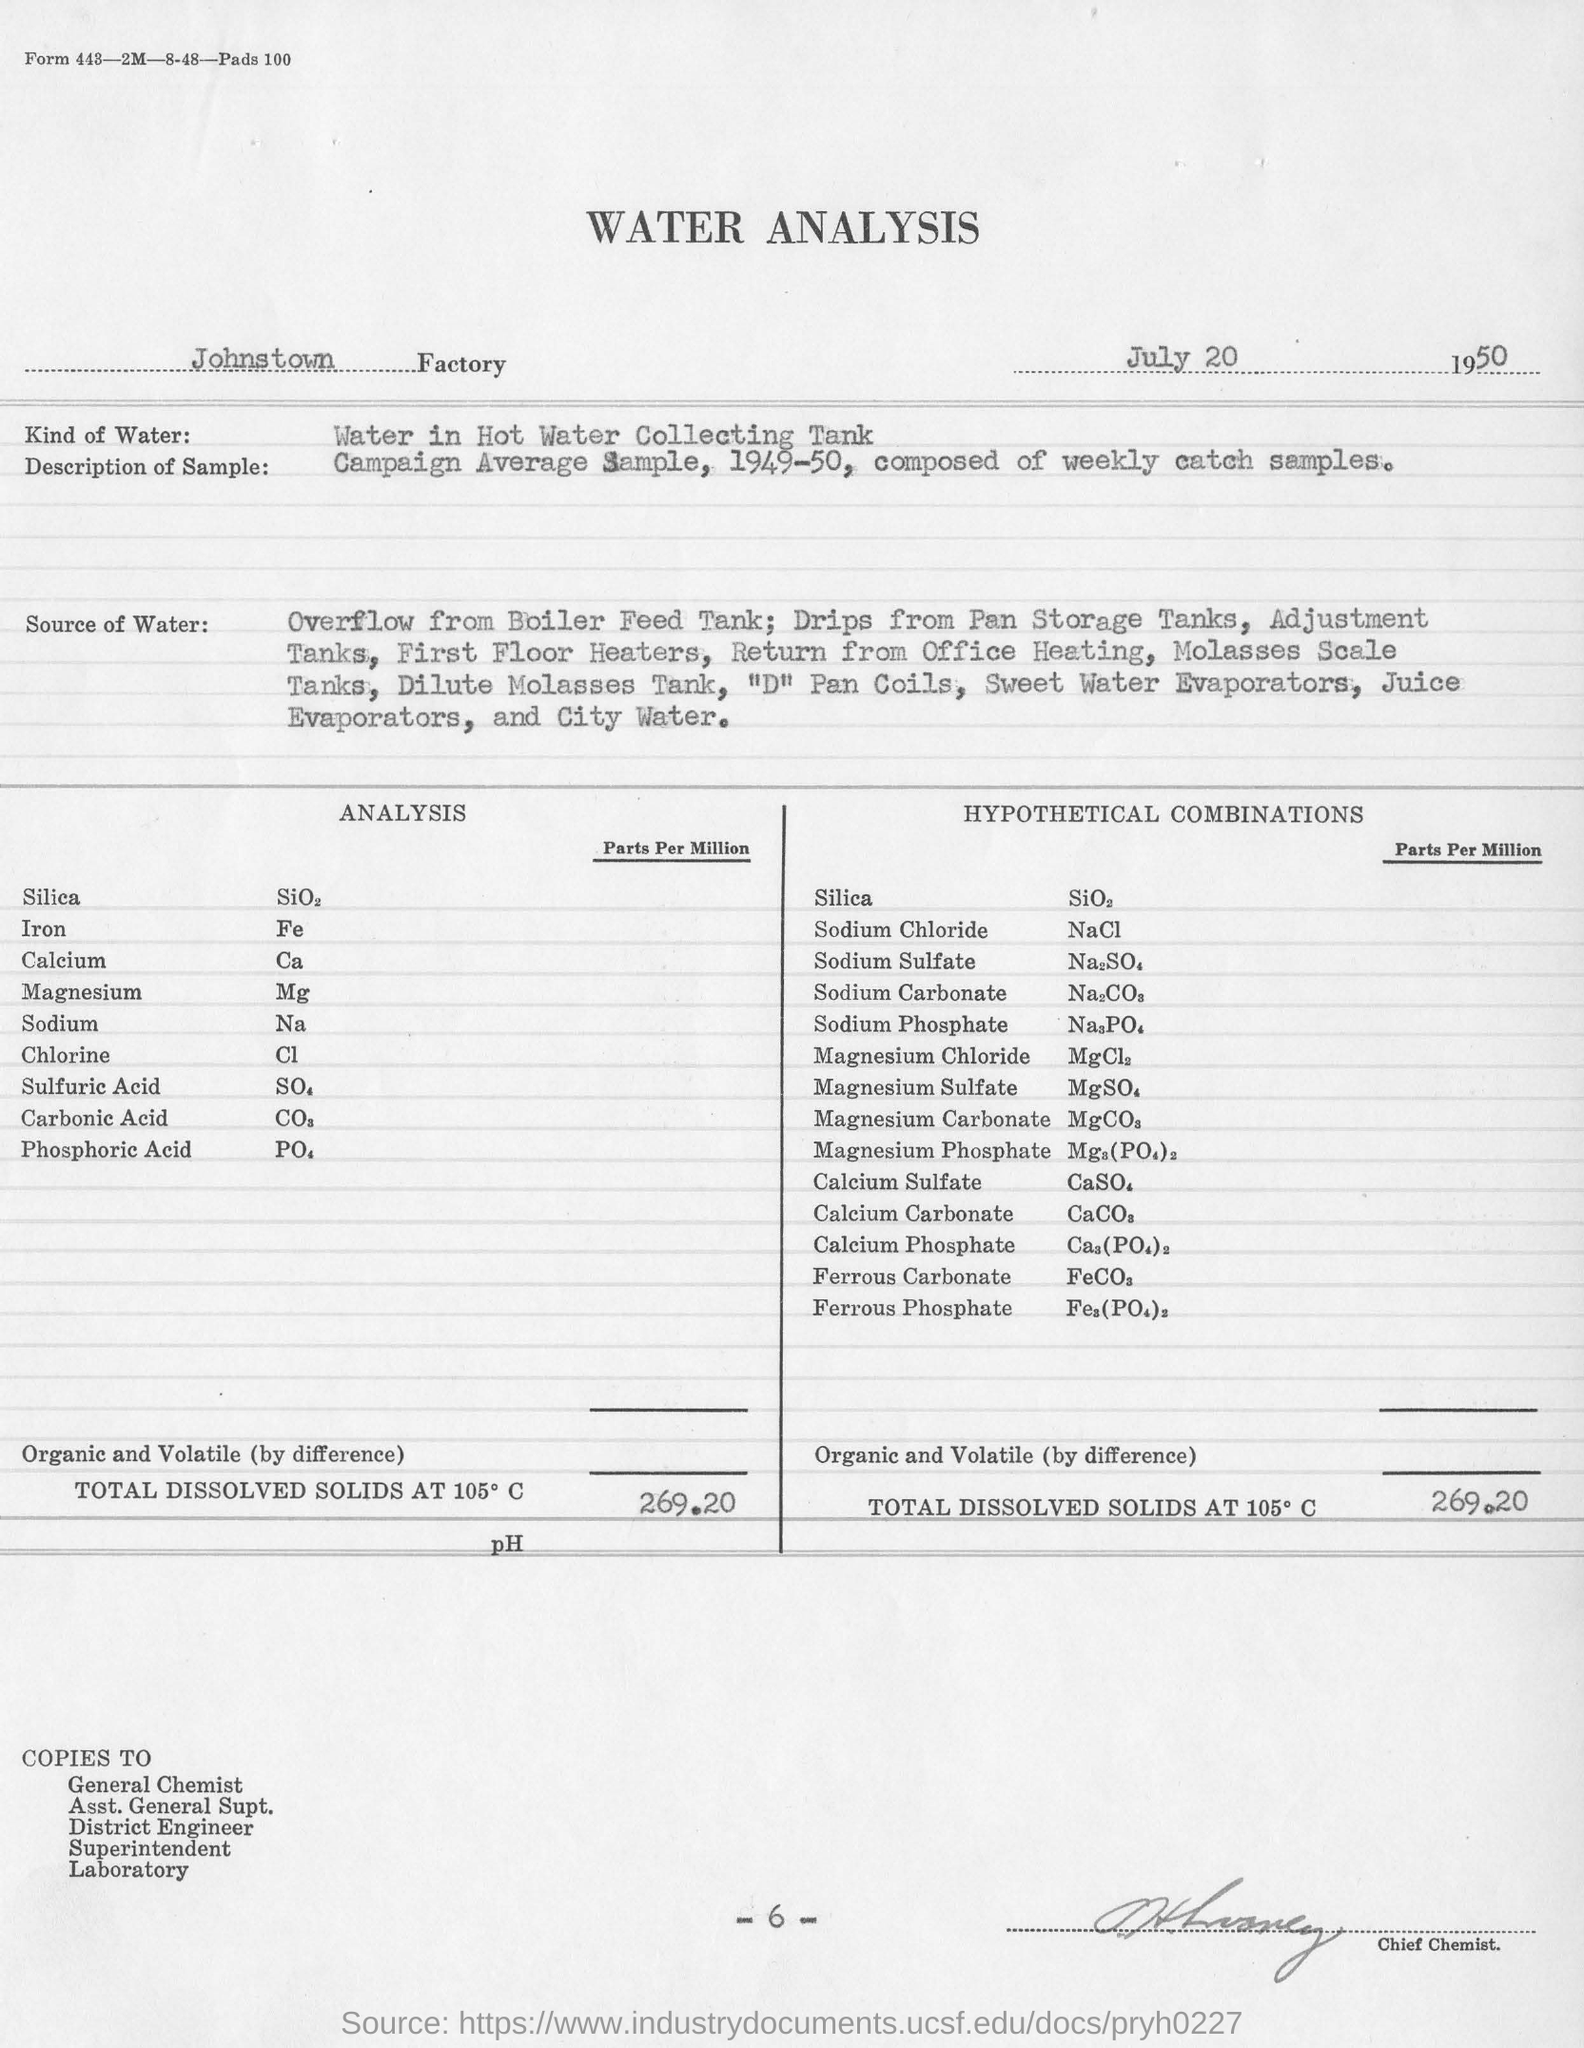In which Factory is the analysis conducted?
Provide a short and direct response. Johnstown Factory. What kind of water is used for analysis?
Make the answer very short. Water in Hot Water Collecting Tank. What is the designation of the person undersigned?
Keep it short and to the point. Chief Chemist. What is the description of the sample taken?
Give a very brief answer. Campaign Average Sample, 1949-50, composed of weekly catch samples. 